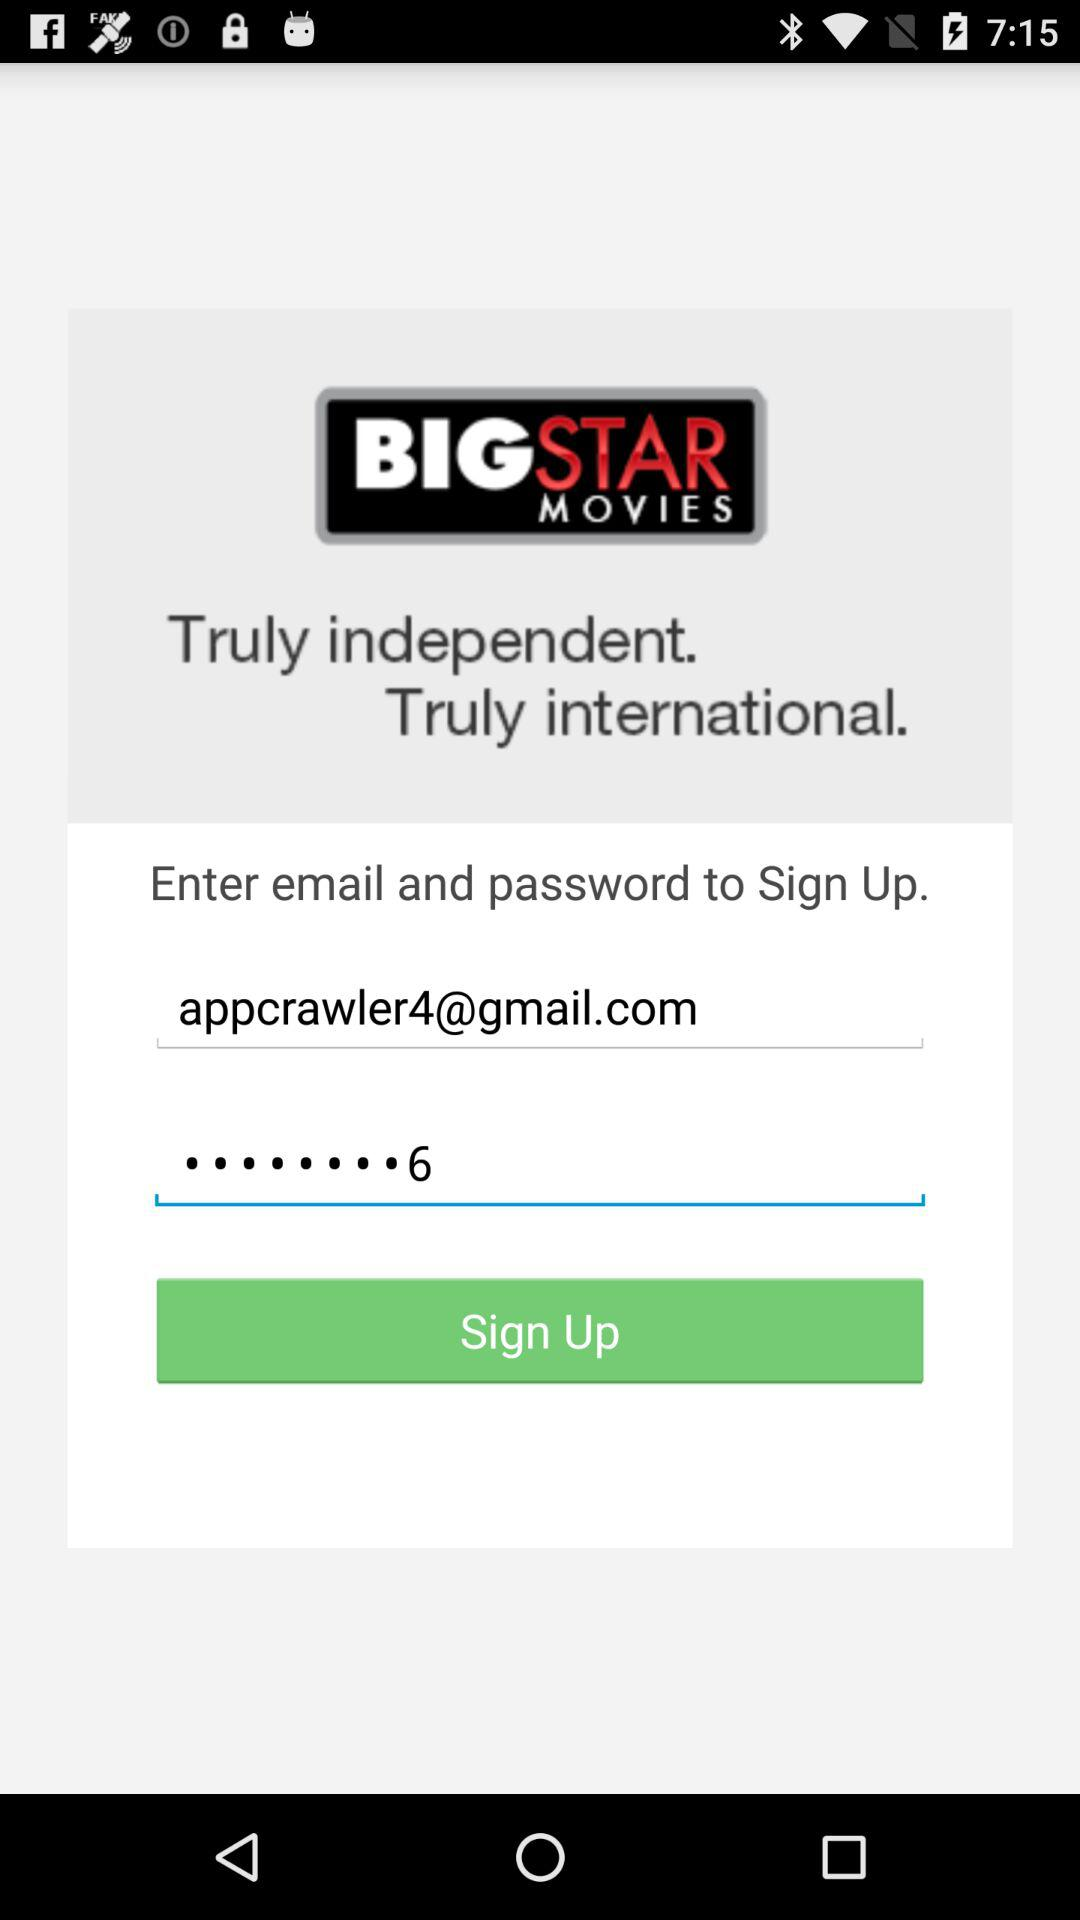What is the name of the application? The name of the application is "BIGSTAR Movies & TV". 